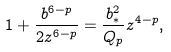<formula> <loc_0><loc_0><loc_500><loc_500>1 + { \frac { b ^ { 6 - p } } { 2 z ^ { 6 - p } } } = { \frac { b _ { * } ^ { 2 } } { Q _ { p } } } z ^ { 4 - p } ,</formula> 